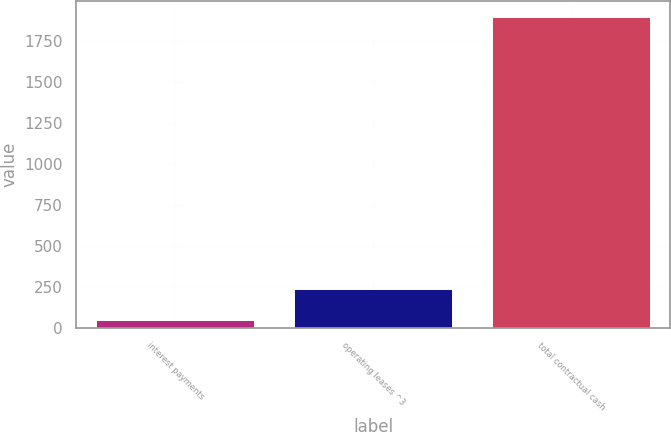Convert chart. <chart><loc_0><loc_0><loc_500><loc_500><bar_chart><fcel>interest payments<fcel>operating leases ^3<fcel>total contractual cash<nl><fcel>50<fcel>234.7<fcel>1897<nl></chart> 